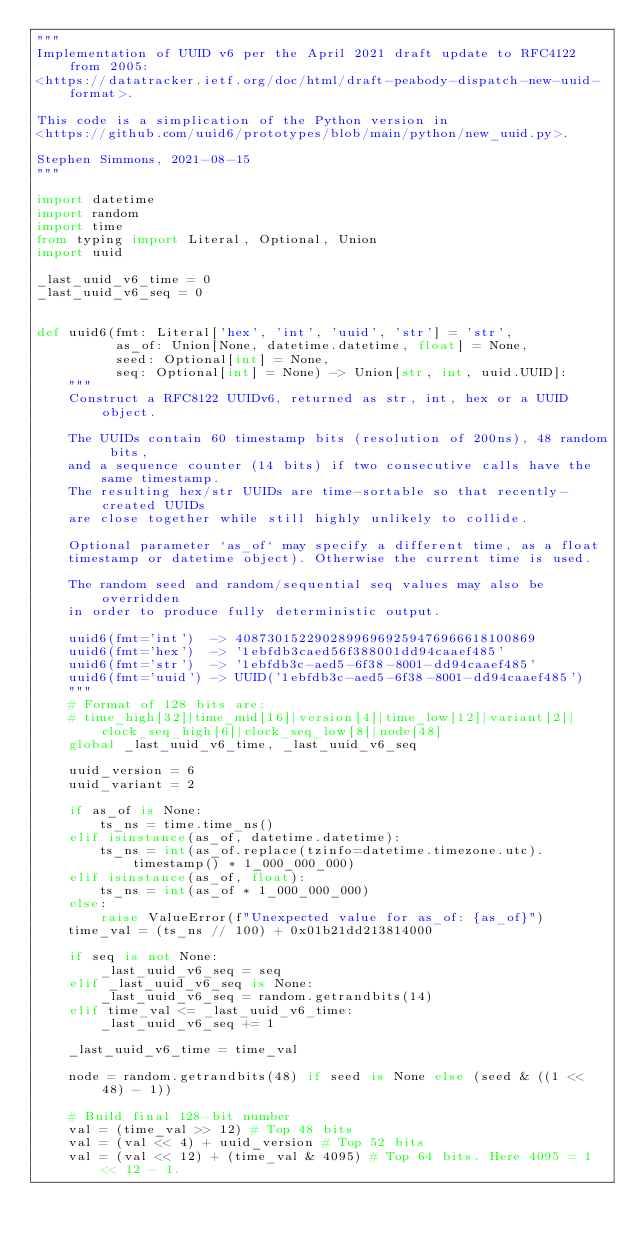Convert code to text. <code><loc_0><loc_0><loc_500><loc_500><_Python_>"""
Implementation of UUID v6 per the April 2021 draft update to RFC4122 from 2005:
<https://datatracker.ietf.org/doc/html/draft-peabody-dispatch-new-uuid-format>.

This code is a simplication of the Python version in
<https://github.com/uuid6/prototypes/blob/main/python/new_uuid.py>.

Stephen Simmons, 2021-08-15
"""

import datetime
import random
import time
from typing import Literal, Optional, Union
import uuid

_last_uuid_v6_time = 0
_last_uuid_v6_seq = 0


def uuid6(fmt: Literal['hex', 'int', 'uuid', 'str'] = 'str',
          as_of: Union[None, datetime.datetime, float] = None,
          seed: Optional[int] = None,
          seq: Optional[int] = None) -> Union[str, int, uuid.UUID]:
    """
    Construct a RFC8122 UUIDv6, returned as str, int, hex or a UUID object.
    
    The UUIDs contain 60 timestamp bits (resolution of 200ns), 48 random bits,
    and a sequence counter (14 bits) if two consecutive calls have the same timestamp.
    The resulting hex/str UUIDs are time-sortable so that recently-created UUIDs
    are close together while still highly unlikely to collide.
    
    Optional parameter `as_of` may specify a different time, as a float 
    timestamp or datetime object). Otherwise the current time is used.
    
    The random seed and random/sequential seq values may also be overridden
    in order to produce fully deterministic output.
    
    uuid6(fmt='int')  -> 40873015229028996969259476966618100869
    uuid6(fmt='hex')  -> '1ebfdb3caed56f388001dd94caaef485'
    uuid6(fmt='str')  -> '1ebfdb3c-aed5-6f38-8001-dd94caaef485'
    uuid6(fmt='uuid') -> UUID('1ebfdb3c-aed5-6f38-8001-dd94caaef485')
    """
    # Format of 128 bits are:
    # time_high[32]|time_mid[16]|version[4]|time_low[12]|variant[2]|clock_seq_high[6]|clock_seq_low[8]|node[48]
    global _last_uuid_v6_time, _last_uuid_v6_seq

    uuid_version = 6
    uuid_variant = 2

    if as_of is None:
        ts_ns = time.time_ns()
    elif isinstance(as_of, datetime.datetime):
        ts_ns = int(as_of.replace(tzinfo=datetime.timezone.utc).timestamp() * 1_000_000_000)
    elif isinstance(as_of, float):
        ts_ns = int(as_of * 1_000_000_000)
    else:
        raise ValueError(f"Unexpected value for as_of: {as_of}")
    time_val = (ts_ns // 100) + 0x01b21dd213814000
    
    if seq is not None:
        _last_uuid_v6_seq = seq
    elif _last_uuid_v6_seq is None:
        _last_uuid_v6_seq = random.getrandbits(14)
    elif time_val <= _last_uuid_v6_time:
        _last_uuid_v6_seq += 1
    
    _last_uuid_v6_time = time_val
    
    node = random.getrandbits(48) if seed is None else (seed & ((1 << 48) - 1))

    # Build final 128-bit number
    val = (time_val >> 12) # Top 48 bits
    val = (val << 4) + uuid_version # Top 52 bits
    val = (val << 12) + (time_val & 4095) # Top 64 bits. Here 4095 = 1 << 12 - 1.</code> 